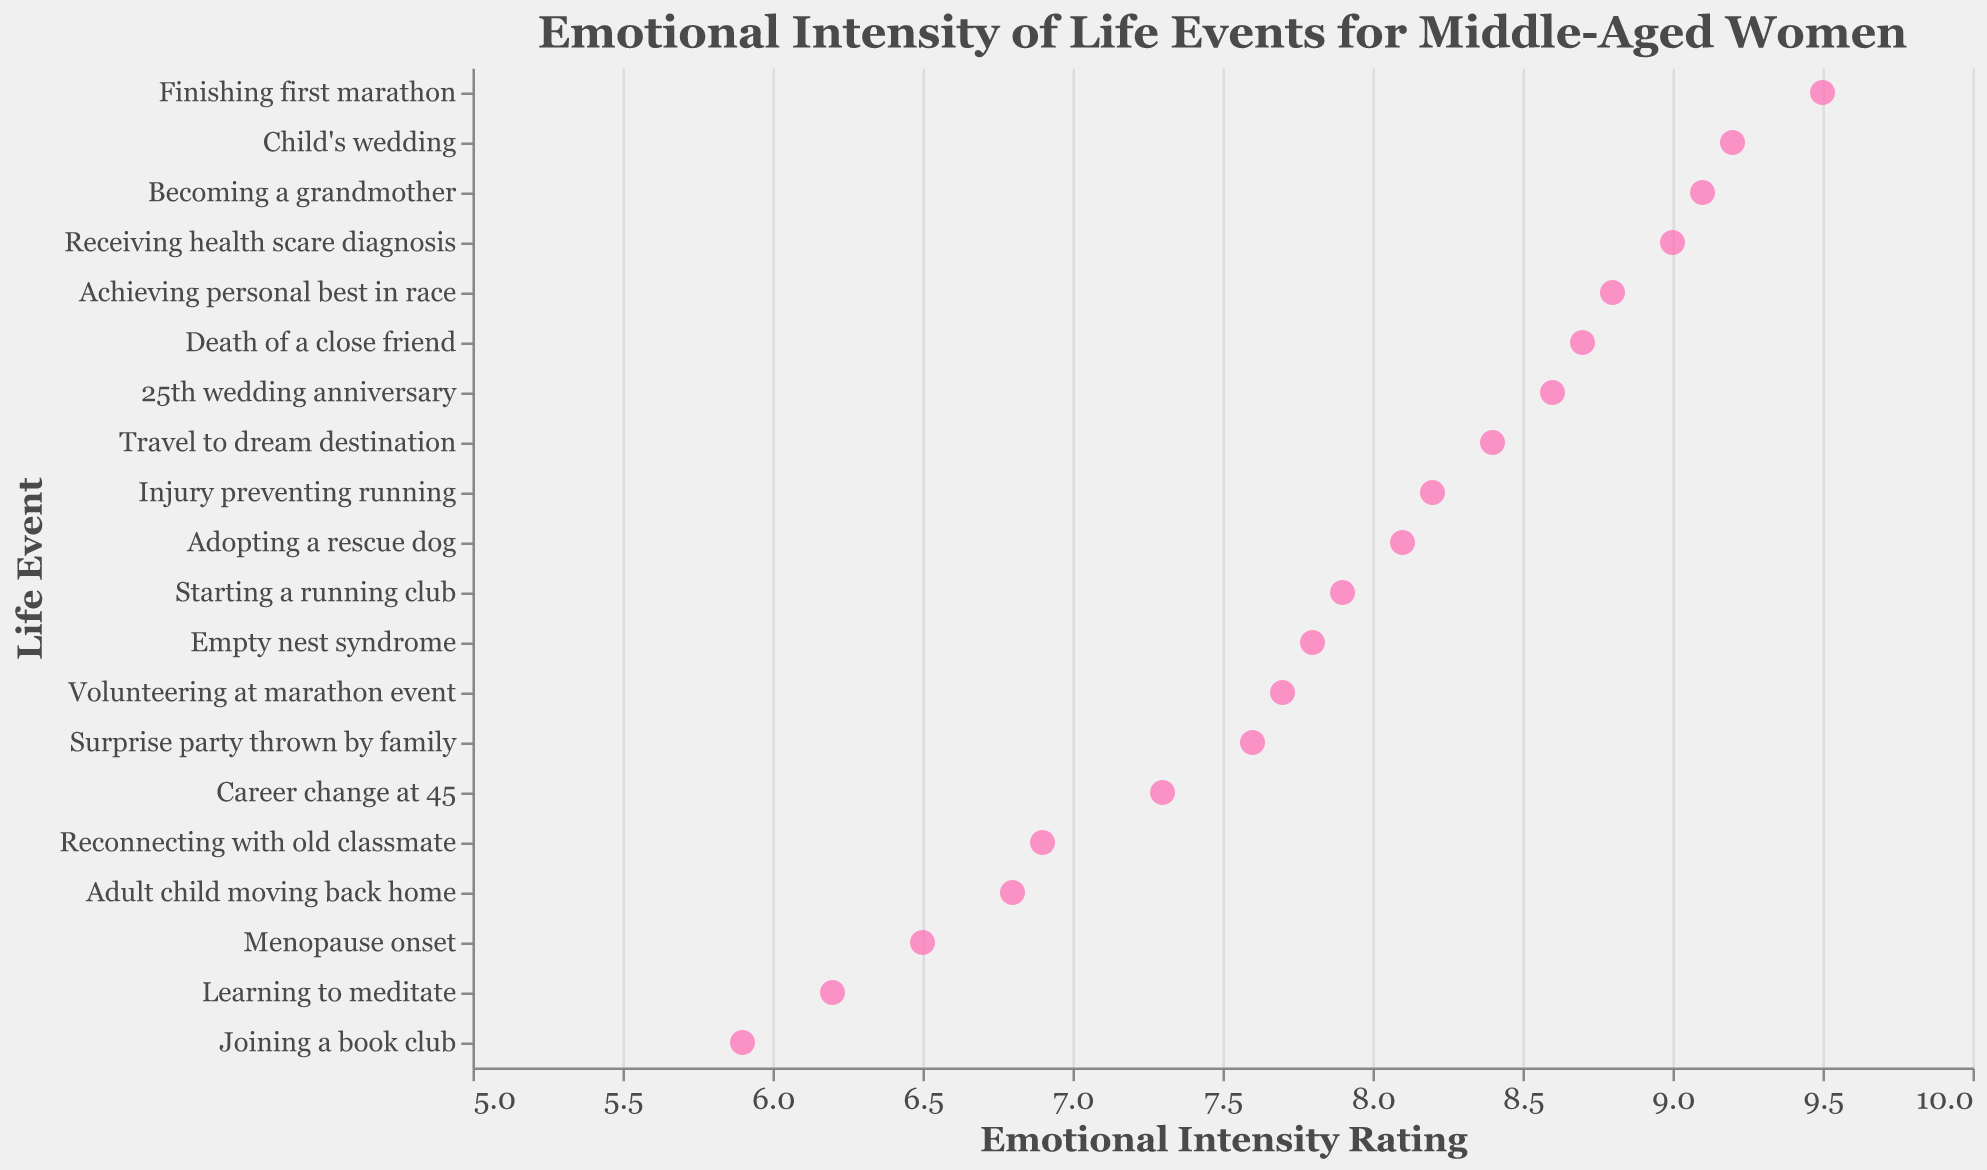What is the title of the plot? The title is located at the top of the plot and provides an overview of the data being visualized. In this case, it indicates that the plot shows the emotional intensity of life events experienced by middle-aged women.
Answer: Emotional Intensity of Life Events for Middle-Aged Women What is the most emotionally intense life event according to the plot? The x-axis represents emotional intensity, and the event with the highest value (closest to 10) is the most intense.
Answer: Finishing first marathon Which event has the lowest emotional intensity rating? Look for the event that is positioned closest to the beginning of the x-axis, indicating the lowest emotional intensity value.
Answer: Joining a book club How many life events have an emotional intensity rating of 8.0 or higher? Count the number of points that are located at 8.0 or to the right on the x-axis.
Answer: 11 What is the emotional intensity rating for the event "Receiving health scare diagnosis"? Identify the y-axis position corresponding to this event and read the x-axis value at that point.
Answer: 9.0 How does the emotional intensity of "Becoming a grandmother" compare to "Child's wedding"? Locate both events on the y-axis and compare their positions along the x-axis to determine which is higher or if they are the same.
Answer: Becoming a grandmother is slightly less intense (9.1 vs. 9.2) What is the difference in emotional intensity between "Achieving personal best in race" and "Starting a running club"? Identify the x-axis values for both events and subtract the smaller from the larger value.
Answer: 8.8 - 7.9 = 0.9 What are the top three most emotionally intense life events? Sort all the life events by their emotional intensity ratings and pick the top three.
Answer: Finishing first marathon, Child's wedding, Receiving health scare diagnosis Which event is more emotionally intense, "Empty nest syndrome" or "Adult child moving back home"? Compare the x-axis values of both events to determine which one is further to the right.
Answer: Empty nest syndrome Is "Adopting a rescue dog" more or less emotionally intense than "Injury preventing running"? Locate both events on the y-axis and compare their positions along the x-axis to see which one is to the right.
Answer: Less 